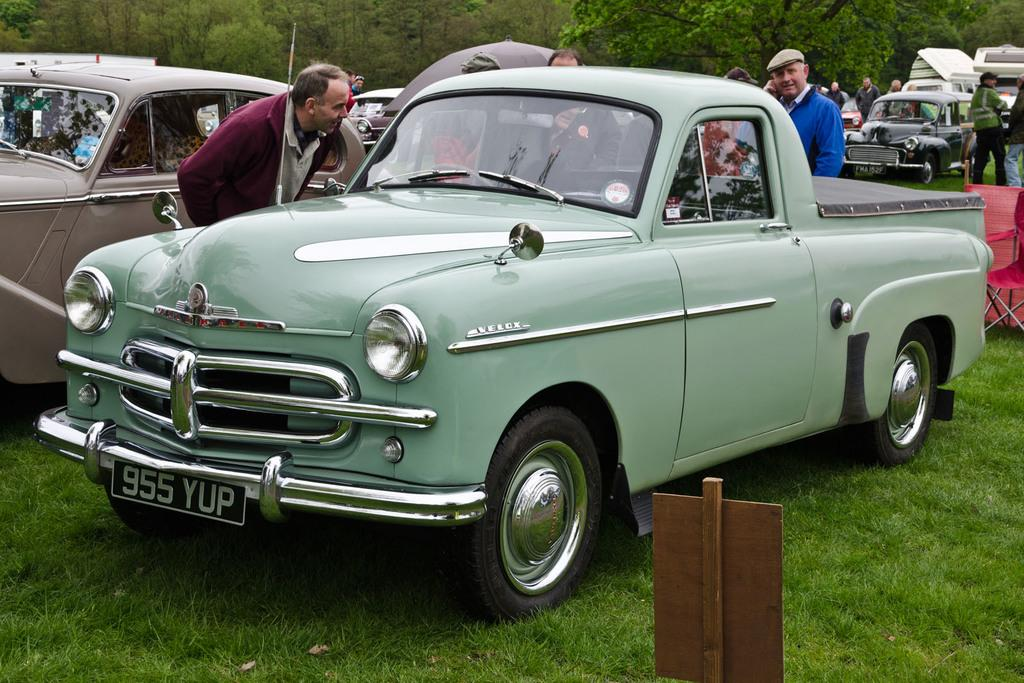Who or what can be seen in the image? There are people and vehicles in the image. What type of natural elements are present in the image? There are trees in the image, and the ground is covered with grass. What else can be observed in the image? There are objects visible in the image. What type of lace can be seen on the people's clothing in the image? There is no lace visible on the people's clothing in the image. How many men are present in the image? The provided facts do not specify the gender of the people in the image, so it cannot be determined how many men are present. 